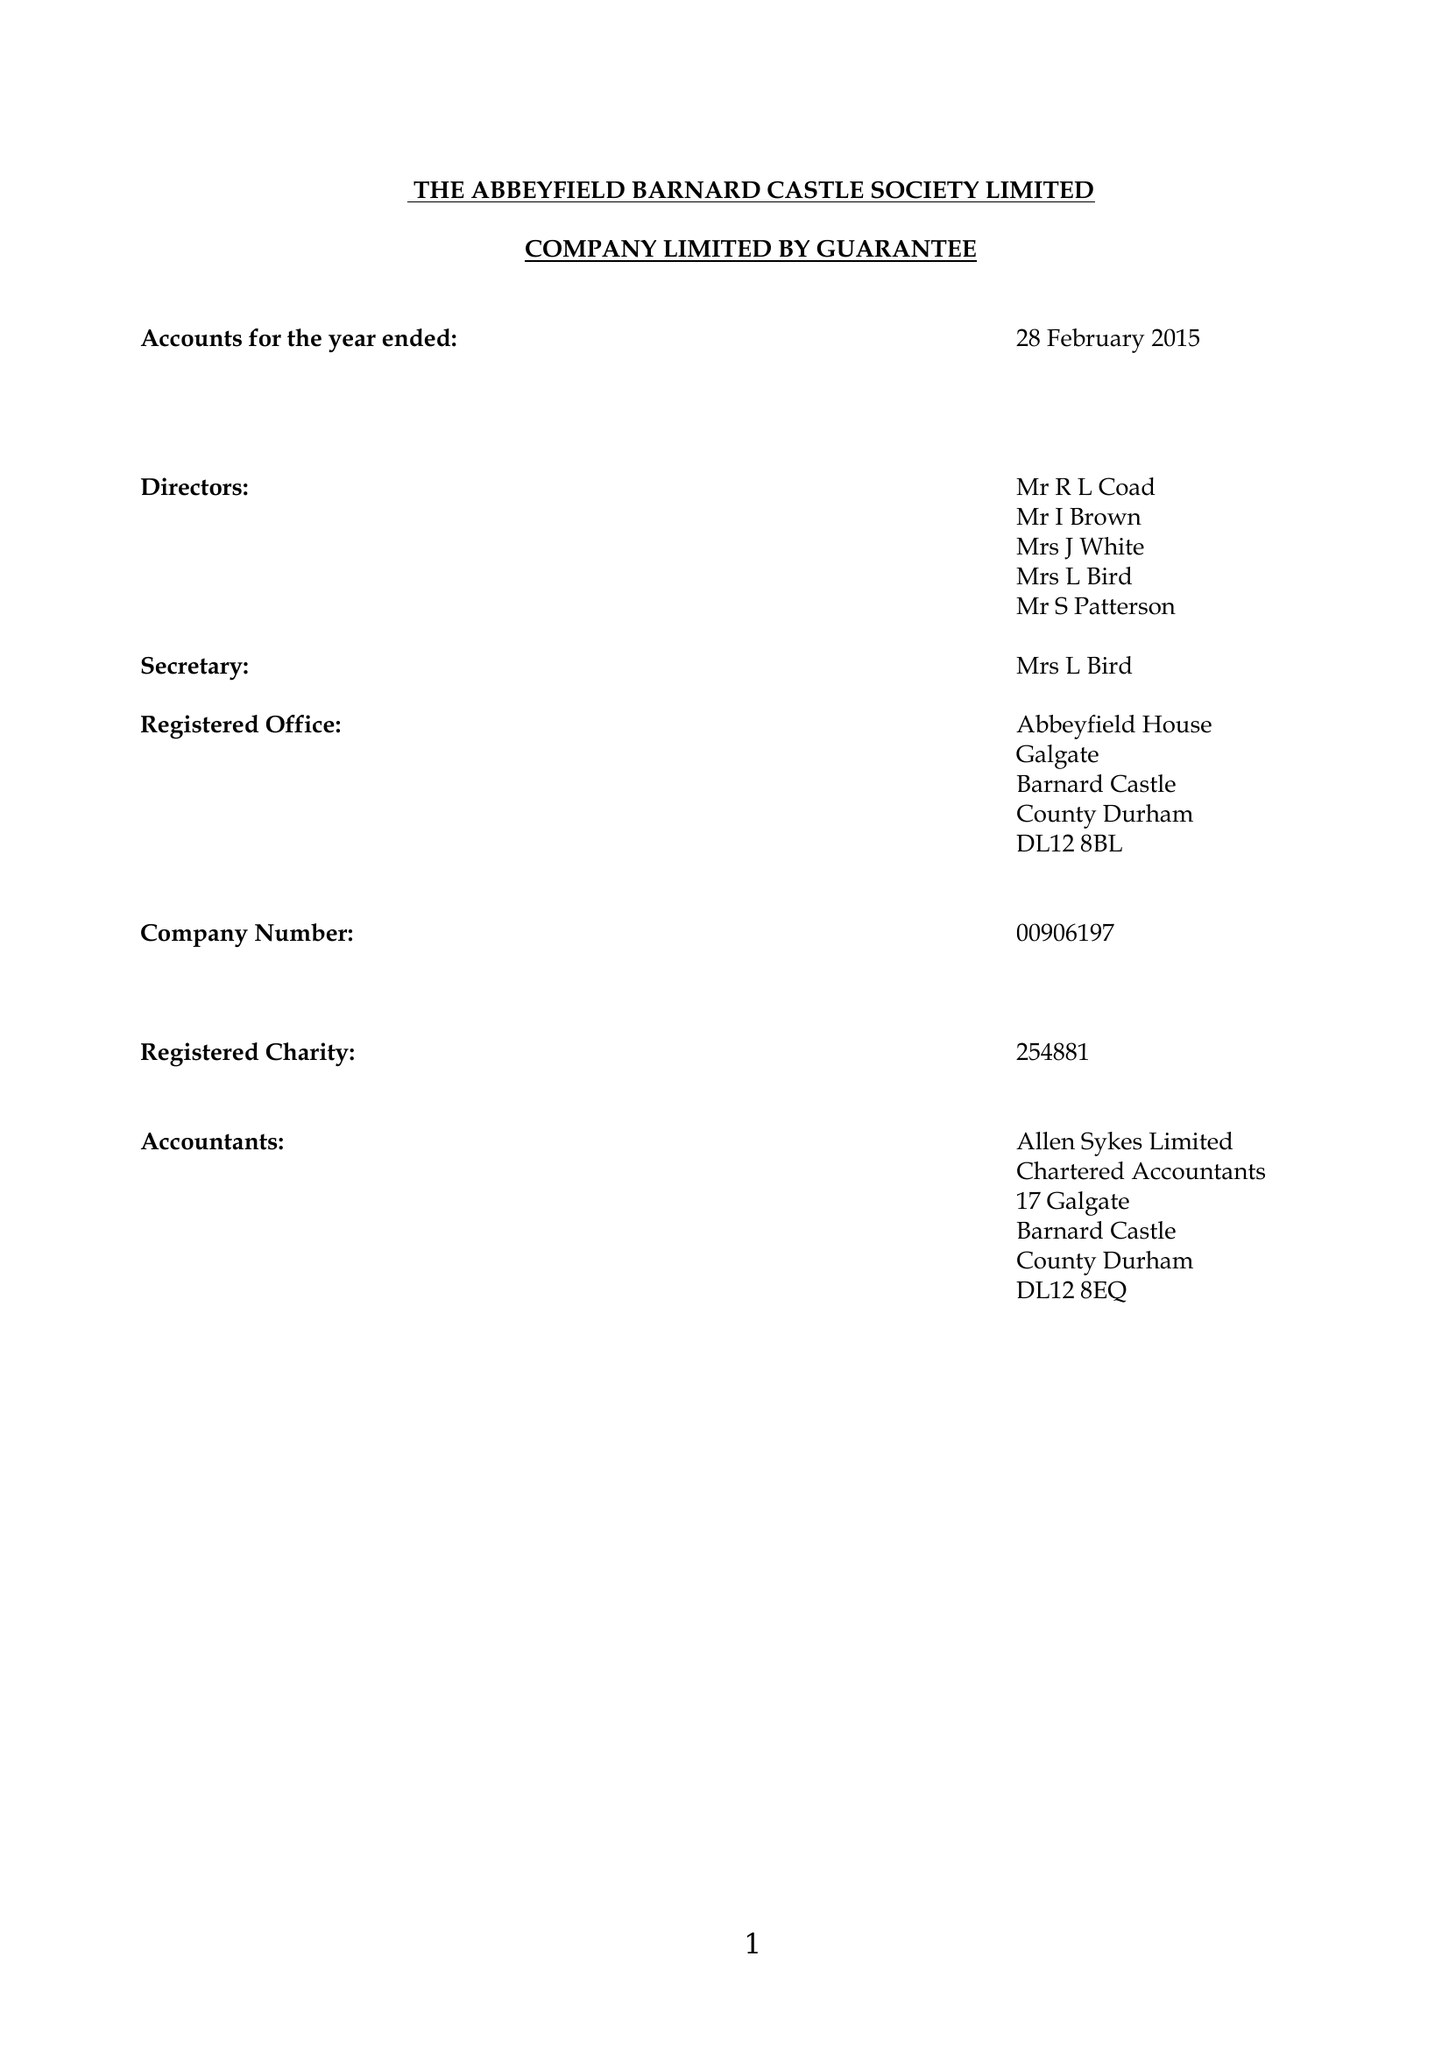What is the value for the address__postcode?
Answer the question using a single word or phrase. DL12 8BL 